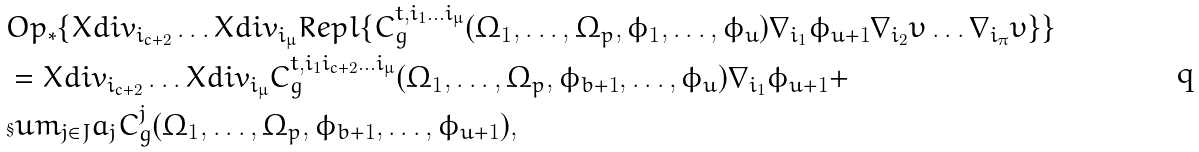<formula> <loc_0><loc_0><loc_500><loc_500>& O p _ { * } \{ X d i v _ { i _ { c + 2 } } \dots X d i v _ { i _ { \mu } } R e p l \{ C ^ { t , i _ { 1 } \dots i _ { \mu } } _ { g } ( \Omega _ { 1 } , \dots , \Omega _ { p } , \phi _ { 1 } , \dots , \phi _ { u } ) \nabla _ { i _ { 1 } } \phi _ { u + 1 } \nabla _ { i _ { 2 } } \upsilon \dots \nabla _ { i _ { \pi } } \upsilon \} \} \\ & = X d i v _ { i _ { c + 2 } } \dots X d i v _ { i _ { \mu } } C ^ { t , i _ { 1 } i _ { c + 2 } \dots i _ { \mu } } _ { g } ( \Omega _ { 1 } , \dots , \Omega _ { p } , \phi _ { b + 1 } , \dots , \phi _ { u } ) \nabla _ { i _ { 1 } } \phi _ { u + 1 } + \\ & \S u m _ { j \in J } a _ { j } C ^ { j } _ { g } ( \Omega _ { 1 } , \dots , \Omega _ { p } , \phi _ { b + 1 } , \dots , \phi _ { u + 1 } ) ,</formula> 